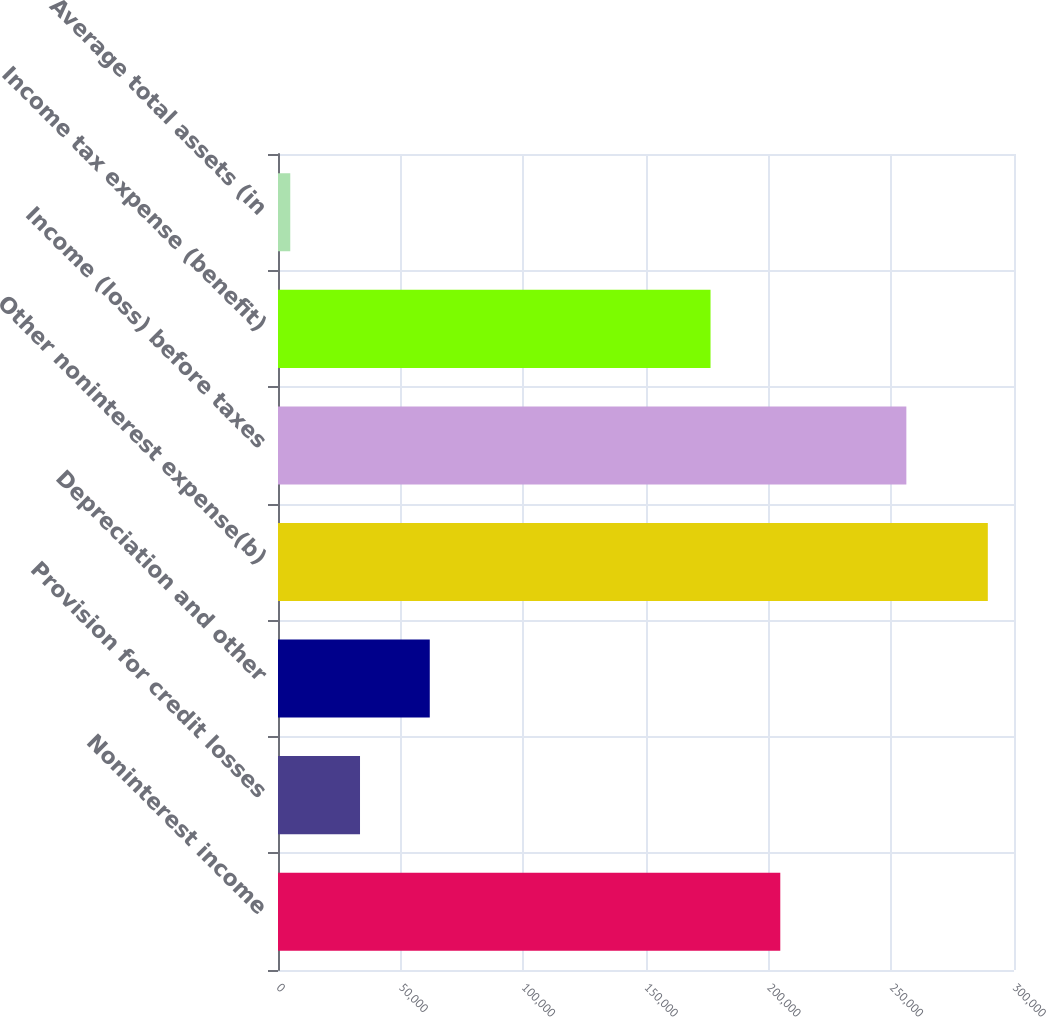<chart> <loc_0><loc_0><loc_500><loc_500><bar_chart><fcel>Noninterest income<fcel>Provision for credit losses<fcel>Depreciation and other<fcel>Other noninterest expense(b)<fcel>Income (loss) before taxes<fcel>Income tax expense (benefit)<fcel>Average total assets (in<nl><fcel>204736<fcel>33431.2<fcel>61864.4<fcel>289330<fcel>256124<fcel>176303<fcel>4998<nl></chart> 